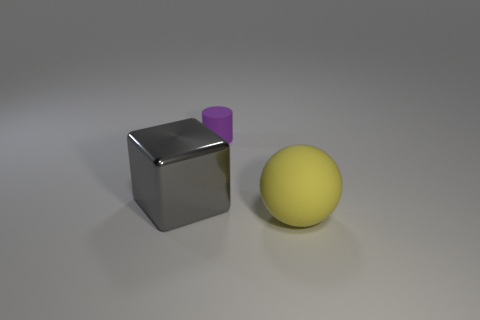Add 3 big brown rubber blocks. How many objects exist? 6 Subtract all balls. How many objects are left? 2 Subtract all cyan balls. How many cyan cylinders are left? 0 Subtract all gray metallic cubes. Subtract all tiny rubber objects. How many objects are left? 1 Add 2 yellow things. How many yellow things are left? 3 Add 3 yellow objects. How many yellow objects exist? 4 Subtract 0 cyan balls. How many objects are left? 3 Subtract 1 blocks. How many blocks are left? 0 Subtract all red cylinders. Subtract all red blocks. How many cylinders are left? 1 